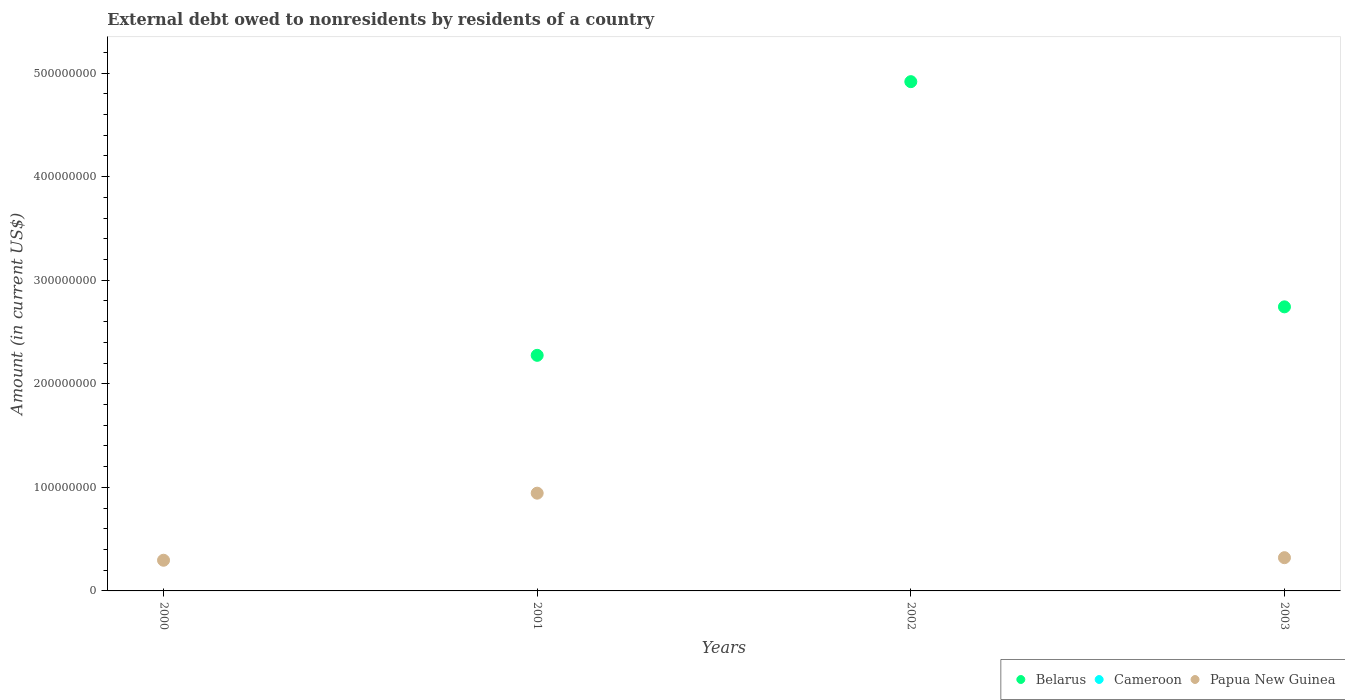What is the external debt owed by residents in Papua New Guinea in 2001?
Keep it short and to the point. 9.44e+07. Across all years, what is the maximum external debt owed by residents in Papua New Guinea?
Offer a terse response. 9.44e+07. What is the total external debt owed by residents in Belarus in the graph?
Your response must be concise. 9.94e+08. What is the difference between the external debt owed by residents in Papua New Guinea in 2001 and that in 2003?
Offer a very short reply. 6.23e+07. What is the difference between the external debt owed by residents in Papua New Guinea in 2003 and the external debt owed by residents in Cameroon in 2001?
Ensure brevity in your answer.  3.21e+07. What is the average external debt owed by residents in Cameroon per year?
Give a very brief answer. 0. In the year 2001, what is the difference between the external debt owed by residents in Papua New Guinea and external debt owed by residents in Belarus?
Give a very brief answer. -1.33e+08. In how many years, is the external debt owed by residents in Cameroon greater than 420000000 US$?
Your answer should be very brief. 0. What is the ratio of the external debt owed by residents in Belarus in 2002 to that in 2003?
Ensure brevity in your answer.  1.79. What is the difference between the highest and the second highest external debt owed by residents in Belarus?
Ensure brevity in your answer.  2.17e+08. What is the difference between the highest and the lowest external debt owed by residents in Papua New Guinea?
Your response must be concise. 9.44e+07. In how many years, is the external debt owed by residents in Papua New Guinea greater than the average external debt owed by residents in Papua New Guinea taken over all years?
Provide a succinct answer. 1. Is the external debt owed by residents in Papua New Guinea strictly less than the external debt owed by residents in Belarus over the years?
Ensure brevity in your answer.  No. How many years are there in the graph?
Offer a terse response. 4. What is the difference between two consecutive major ticks on the Y-axis?
Provide a succinct answer. 1.00e+08. Are the values on the major ticks of Y-axis written in scientific E-notation?
Ensure brevity in your answer.  No. Where does the legend appear in the graph?
Your answer should be very brief. Bottom right. How are the legend labels stacked?
Keep it short and to the point. Horizontal. What is the title of the graph?
Provide a succinct answer. External debt owed to nonresidents by residents of a country. Does "French Polynesia" appear as one of the legend labels in the graph?
Your answer should be compact. No. What is the label or title of the X-axis?
Keep it short and to the point. Years. What is the label or title of the Y-axis?
Offer a very short reply. Amount (in current US$). What is the Amount (in current US$) in Papua New Guinea in 2000?
Offer a very short reply. 2.96e+07. What is the Amount (in current US$) of Belarus in 2001?
Keep it short and to the point. 2.28e+08. What is the Amount (in current US$) in Papua New Guinea in 2001?
Your answer should be compact. 9.44e+07. What is the Amount (in current US$) of Belarus in 2002?
Give a very brief answer. 4.92e+08. What is the Amount (in current US$) of Cameroon in 2002?
Your response must be concise. 0. What is the Amount (in current US$) of Belarus in 2003?
Offer a very short reply. 2.74e+08. What is the Amount (in current US$) in Papua New Guinea in 2003?
Offer a terse response. 3.21e+07. Across all years, what is the maximum Amount (in current US$) of Belarus?
Your answer should be compact. 4.92e+08. Across all years, what is the maximum Amount (in current US$) in Papua New Guinea?
Provide a succinct answer. 9.44e+07. Across all years, what is the minimum Amount (in current US$) of Belarus?
Your answer should be compact. 0. What is the total Amount (in current US$) of Belarus in the graph?
Provide a succinct answer. 9.94e+08. What is the total Amount (in current US$) in Cameroon in the graph?
Ensure brevity in your answer.  0. What is the total Amount (in current US$) of Papua New Guinea in the graph?
Give a very brief answer. 1.56e+08. What is the difference between the Amount (in current US$) in Papua New Guinea in 2000 and that in 2001?
Your response must be concise. -6.48e+07. What is the difference between the Amount (in current US$) of Papua New Guinea in 2000 and that in 2003?
Your answer should be compact. -2.48e+06. What is the difference between the Amount (in current US$) of Belarus in 2001 and that in 2002?
Your answer should be very brief. -2.64e+08. What is the difference between the Amount (in current US$) in Belarus in 2001 and that in 2003?
Ensure brevity in your answer.  -4.68e+07. What is the difference between the Amount (in current US$) of Papua New Guinea in 2001 and that in 2003?
Ensure brevity in your answer.  6.23e+07. What is the difference between the Amount (in current US$) in Belarus in 2002 and that in 2003?
Provide a short and direct response. 2.17e+08. What is the difference between the Amount (in current US$) in Belarus in 2001 and the Amount (in current US$) in Papua New Guinea in 2003?
Offer a very short reply. 1.95e+08. What is the difference between the Amount (in current US$) of Belarus in 2002 and the Amount (in current US$) of Papua New Guinea in 2003?
Offer a terse response. 4.60e+08. What is the average Amount (in current US$) in Belarus per year?
Keep it short and to the point. 2.48e+08. What is the average Amount (in current US$) in Cameroon per year?
Offer a very short reply. 0. What is the average Amount (in current US$) in Papua New Guinea per year?
Offer a very short reply. 3.90e+07. In the year 2001, what is the difference between the Amount (in current US$) in Belarus and Amount (in current US$) in Papua New Guinea?
Your response must be concise. 1.33e+08. In the year 2003, what is the difference between the Amount (in current US$) in Belarus and Amount (in current US$) in Papua New Guinea?
Offer a terse response. 2.42e+08. What is the ratio of the Amount (in current US$) of Papua New Guinea in 2000 to that in 2001?
Ensure brevity in your answer.  0.31. What is the ratio of the Amount (in current US$) in Papua New Guinea in 2000 to that in 2003?
Offer a terse response. 0.92. What is the ratio of the Amount (in current US$) of Belarus in 2001 to that in 2002?
Give a very brief answer. 0.46. What is the ratio of the Amount (in current US$) of Belarus in 2001 to that in 2003?
Provide a short and direct response. 0.83. What is the ratio of the Amount (in current US$) of Papua New Guinea in 2001 to that in 2003?
Your response must be concise. 2.94. What is the ratio of the Amount (in current US$) in Belarus in 2002 to that in 2003?
Your response must be concise. 1.79. What is the difference between the highest and the second highest Amount (in current US$) in Belarus?
Your response must be concise. 2.17e+08. What is the difference between the highest and the second highest Amount (in current US$) in Papua New Guinea?
Offer a terse response. 6.23e+07. What is the difference between the highest and the lowest Amount (in current US$) in Belarus?
Offer a terse response. 4.92e+08. What is the difference between the highest and the lowest Amount (in current US$) in Papua New Guinea?
Make the answer very short. 9.44e+07. 